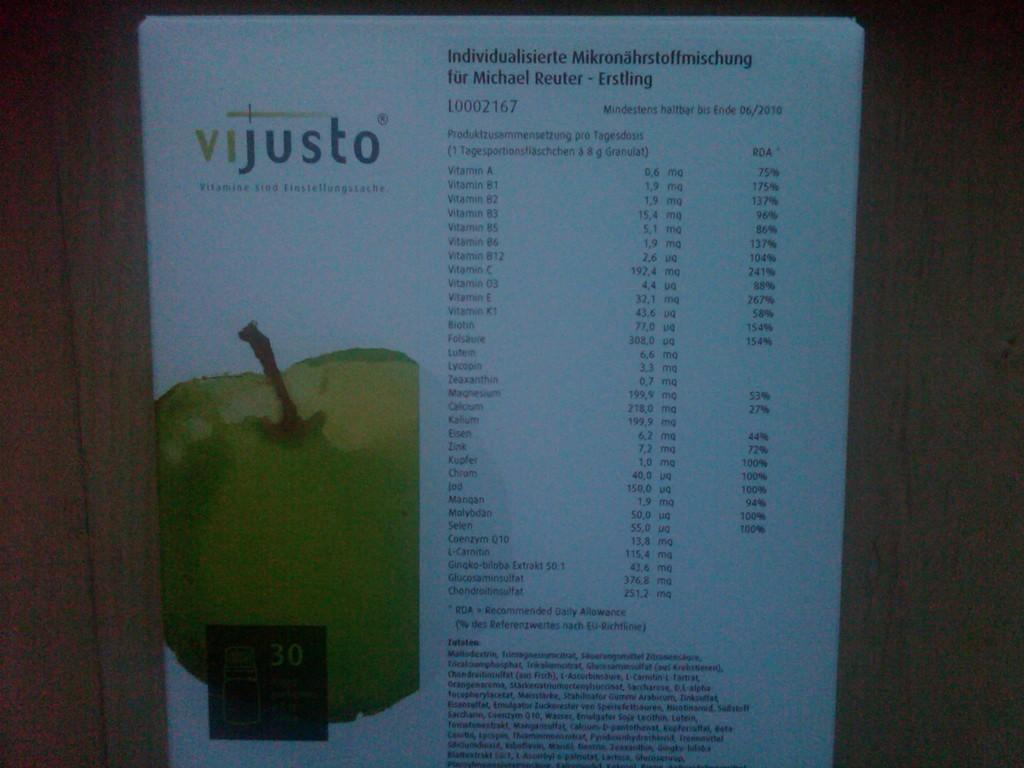<image>
Write a terse but informative summary of the picture. A picture of an apple under the words Vijusto 